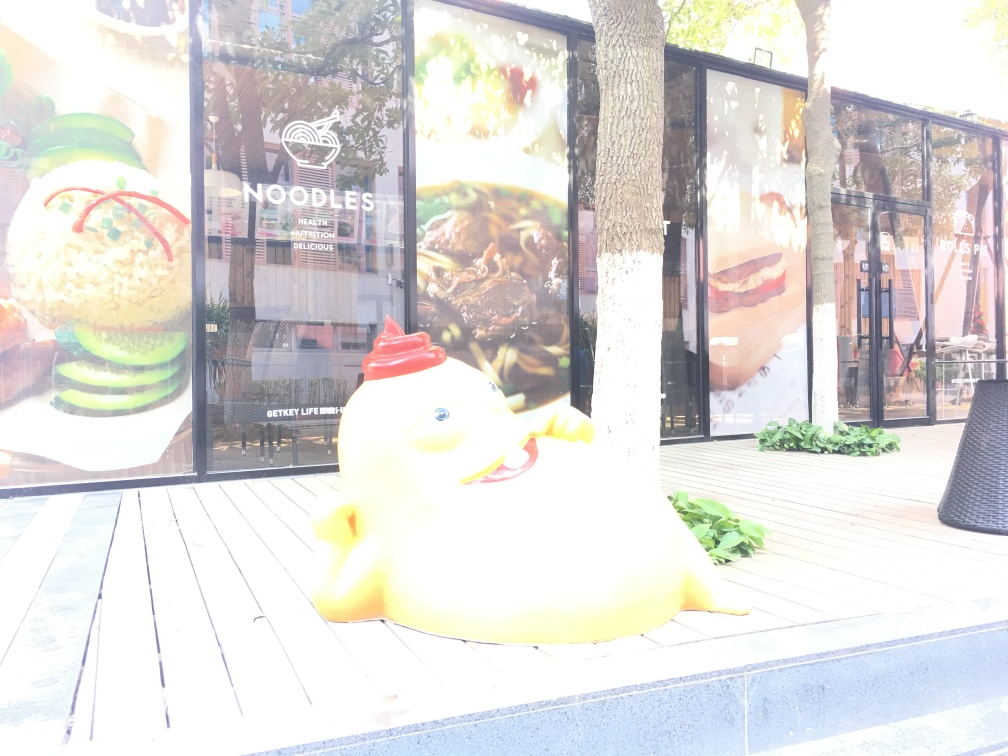Are there any quality issues with this image? Yes, the image appears to be overexposed, which affects the visibility of details, particularly in the background where the light sources are washing out parts of the scene. The subject, which seems to be a colorful statue or structure, is well-captured in terms of color and focus, but the overexposure makes it difficult to appreciate the full context of the surroundings. 